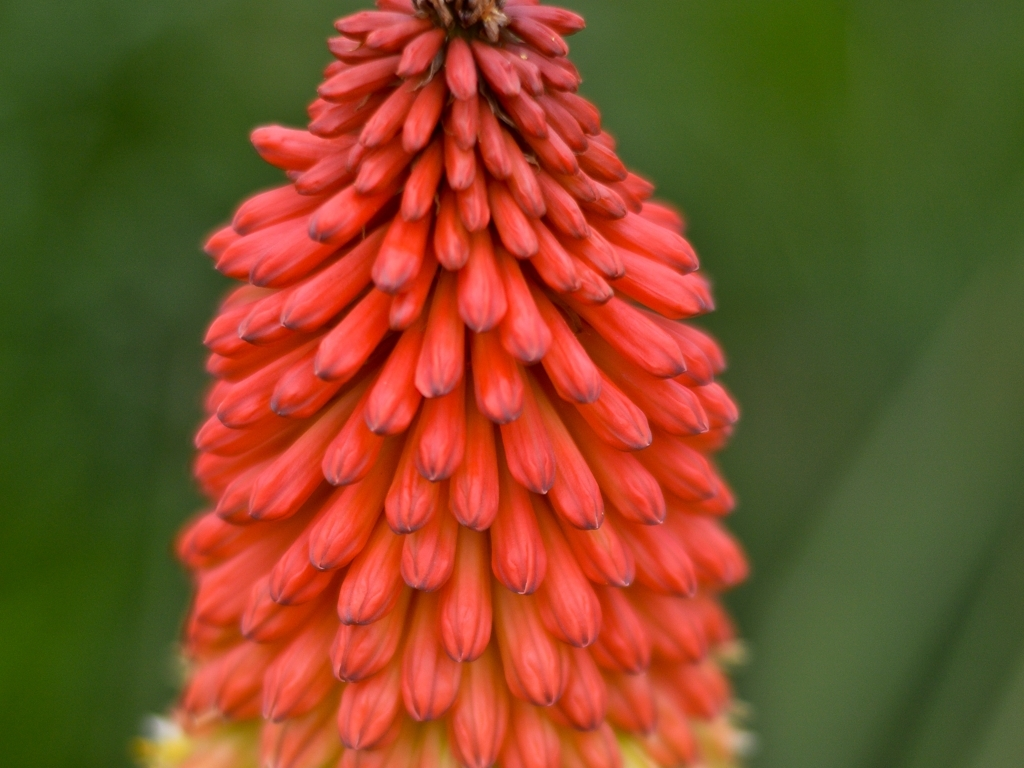Could you suggest the best time of year to plant this flower for optimal growth? The Red Hot Poker thrives when planted in the spring after the threat of frost has passed. It prefers well-draining soil and plenty of sunlight to produce its characteristic blooms in the summer. 